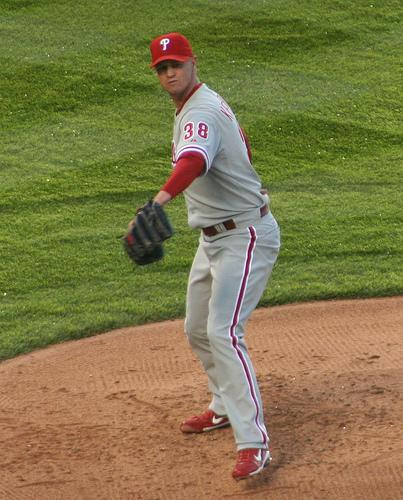Describe what is happening in the image by focusing on the main character's actions. The baseball player, wearing a red and gray uniform, is standing on the pitchers mound and preparing to throw the ball with his black glove extended outward. State what the person in the picture is doing and their appearance. The baseball player, dressed in a red and gray uniform, red hat, and red shoes, is getting ready to pitch the ball with a black glove on his left hand. Point out the main components of the scene involving the baseball player. Main components include the pitcher in his red and gray uniform, the red cap, black glove, red-striped pants, red shoes, and the dirt pitcher's mound. Describe the key features of the person in the picture. The baseball player is wearing a gray and red jersey with the number 38, a red cap with a "P" logo, red Nike-branded shoes, red-striped pants, and a large black glove. Mention the primary activity the person in the image is participating in. The baseball player is in the pitching stance, preparing to throw the baseball with a black glove on his left hand. State the primary focus of the image and its key attributes. The image primarily focuses on a baseball pitcher with a red-striped gray jersey, red hat, black glove, red shoes, and brown belt, getting ready to pitch the ball. Provide a brief summary of the major elements in the image. A male baseball pitcher in a red and gray uniform is preparing to throw the ball, wearing a red hat, black glove, and red Nike shoes on a dirt mound. Summarize the image by highlighting the subject's attire and actions. A male baseball pitcher is preparing to pitch, wearing a gray and red uniform with a red hat, black glove, red-striped pants, and red sneakers. Explain what the baseball player in the image is wearing. The player is dressed in a gray and red uniform with a red cap, number 38 on his shirt, a belt, red-striped pants, and red Nike shoes. Comment on the central subject of the image and their body position. The image's central subject is a baseball pitcher in red and gray attire with an extended glove, ready to throw the ball from a dirt mound. 